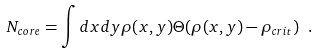Convert formula to latex. <formula><loc_0><loc_0><loc_500><loc_500>N _ { c o r e } = \int d x d y \rho ( x , y ) \Theta ( \rho ( x , y ) - \rho _ { c r i t } ) \ .</formula> 